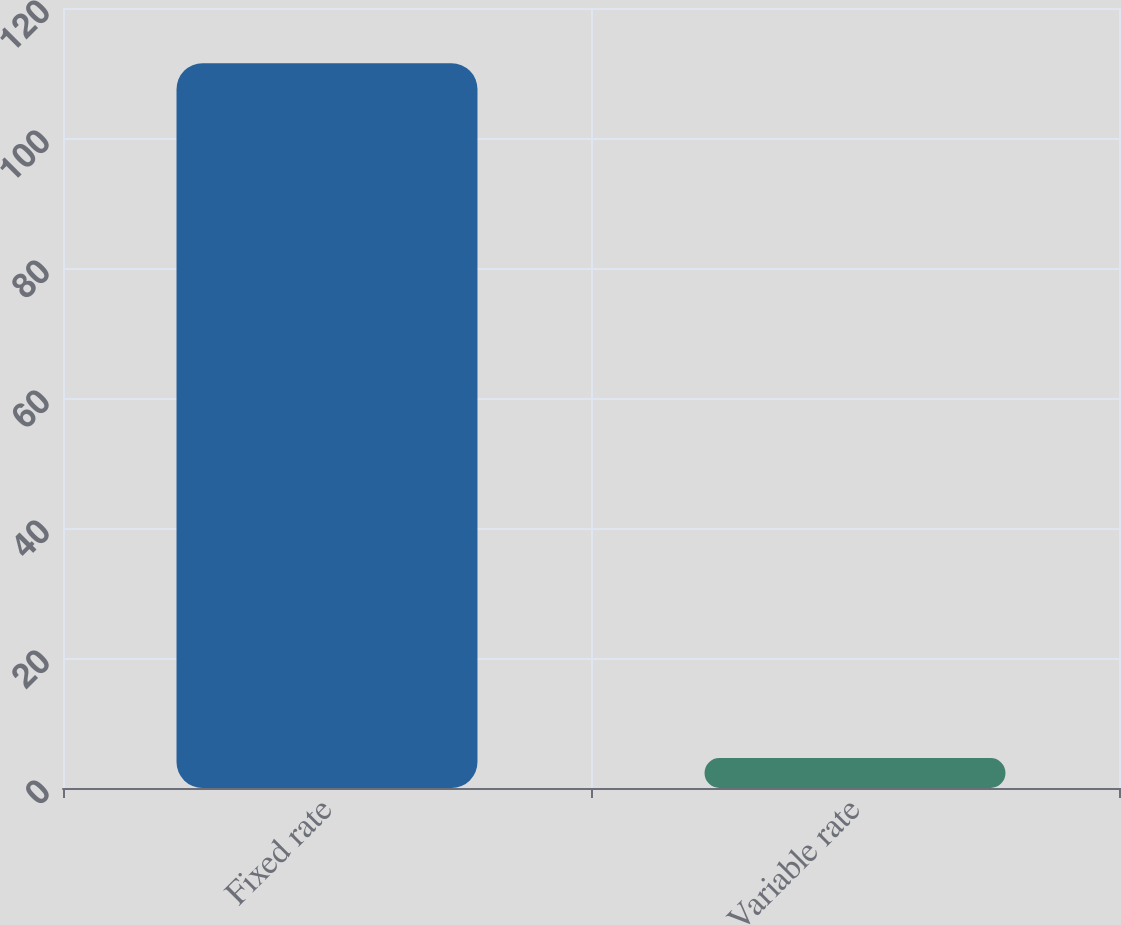Convert chart to OTSL. <chart><loc_0><loc_0><loc_500><loc_500><bar_chart><fcel>Fixed rate<fcel>Variable rate<nl><fcel>111.5<fcel>4.6<nl></chart> 